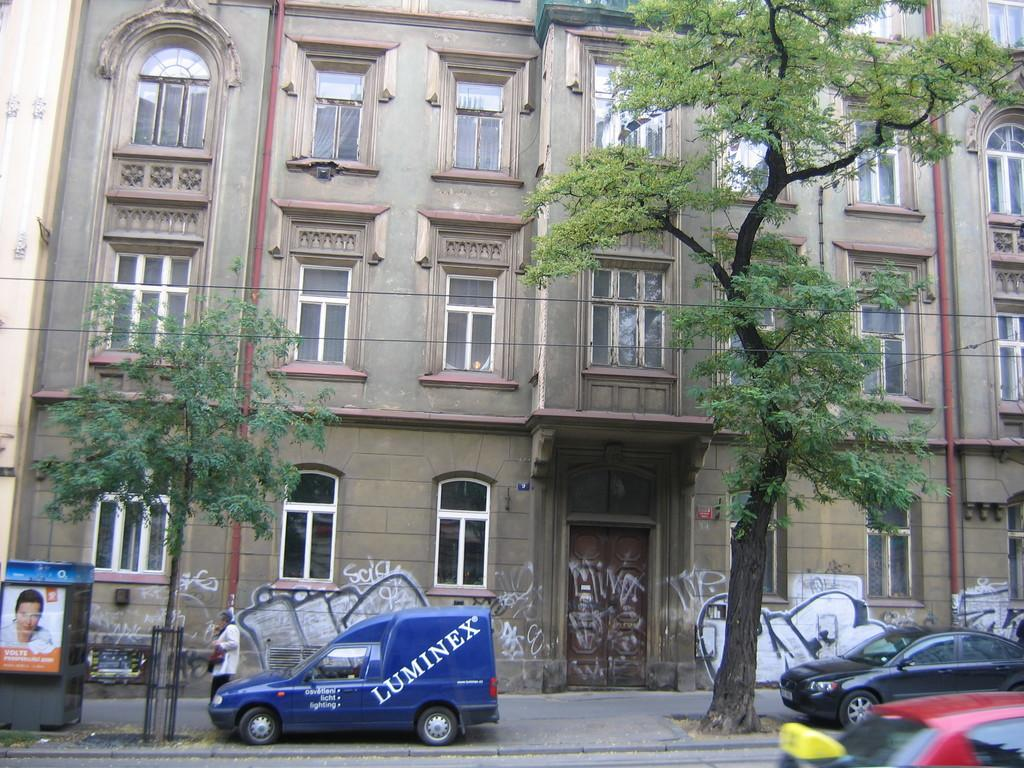<image>
Share a concise interpretation of the image provided. the outside of a building with a blue truck that's parked and says 'luminex' on it 